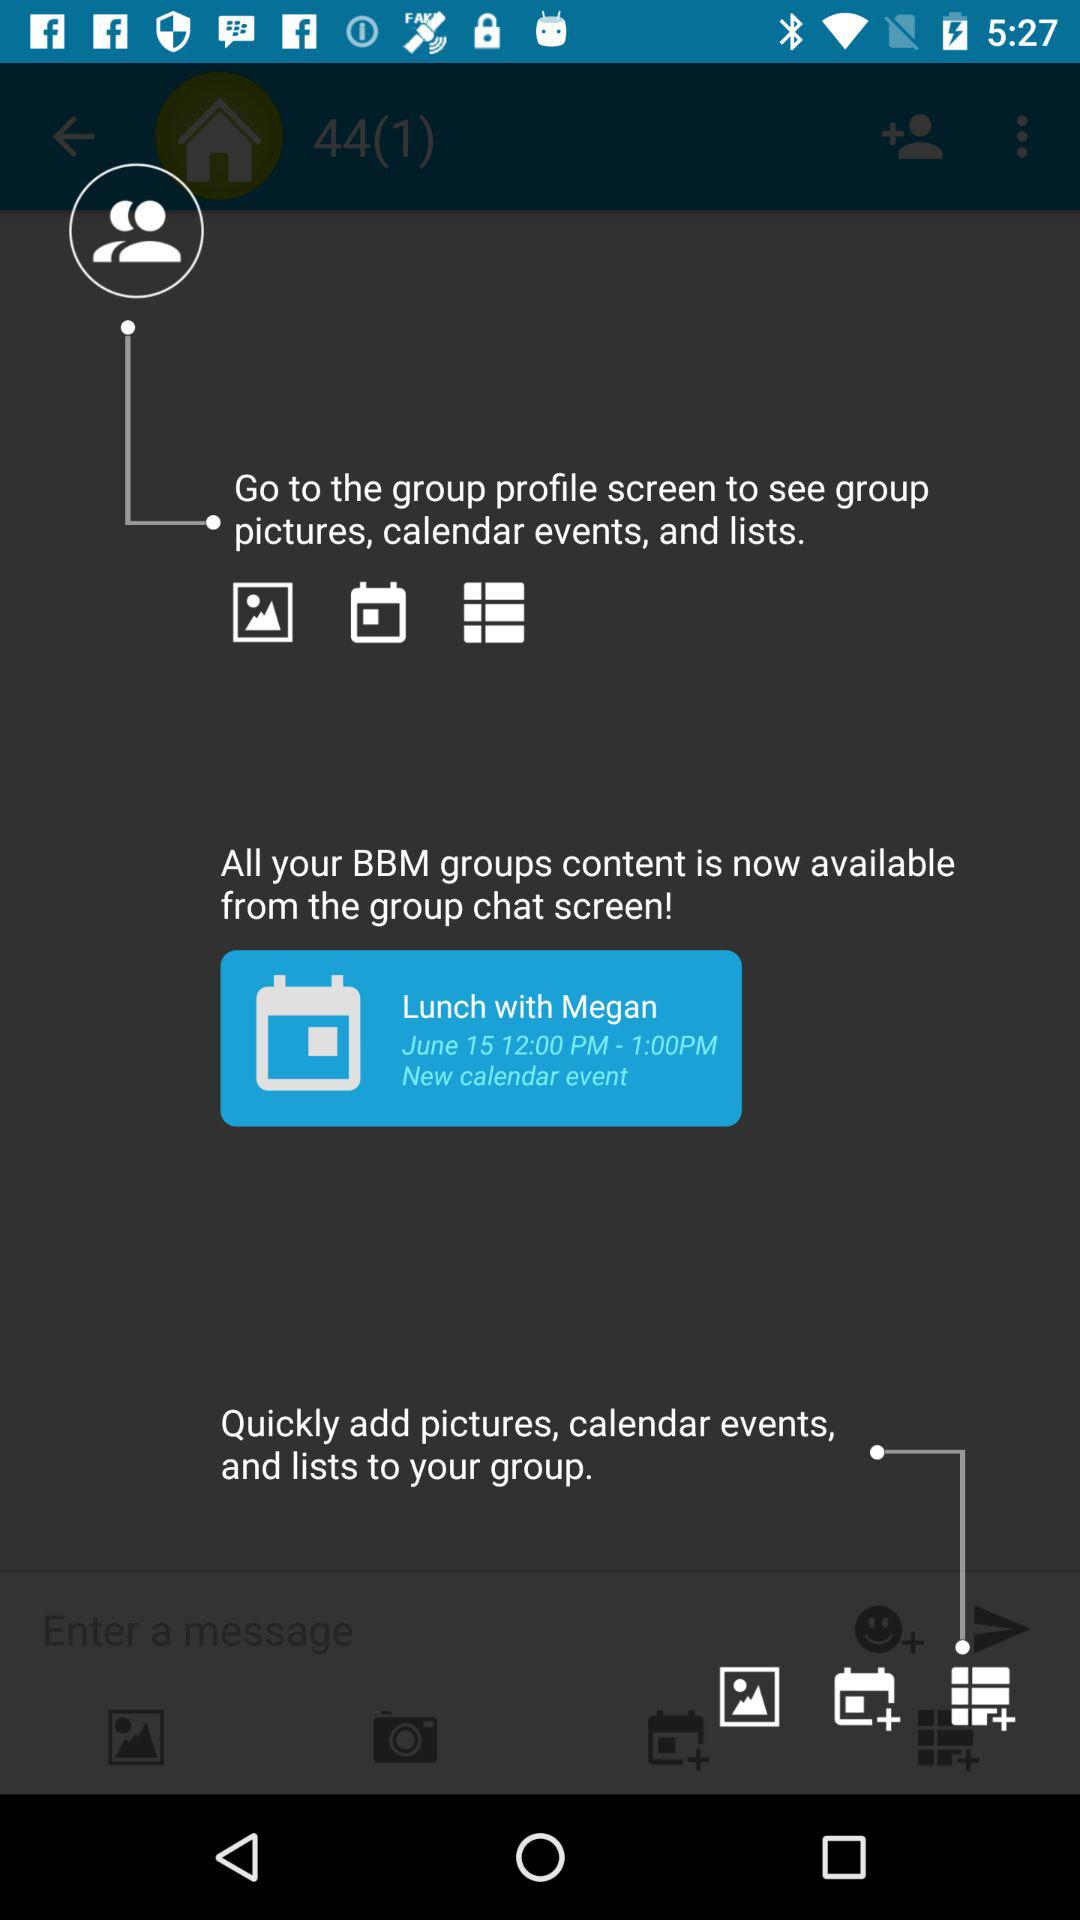What is the time of the event? The time of the event is from 12:00 PM to 1:00 PM. 